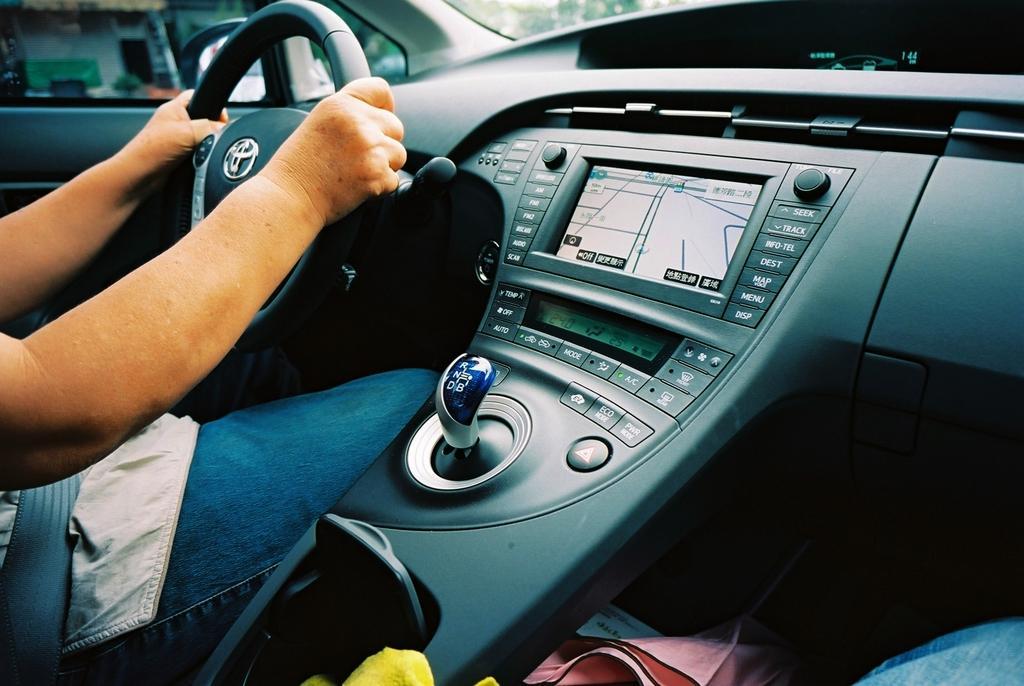How would you summarize this image in a sentence or two? In this picture we can see a person's hands holding a steering of a vehicle and in the background we can see a shed, trees. 